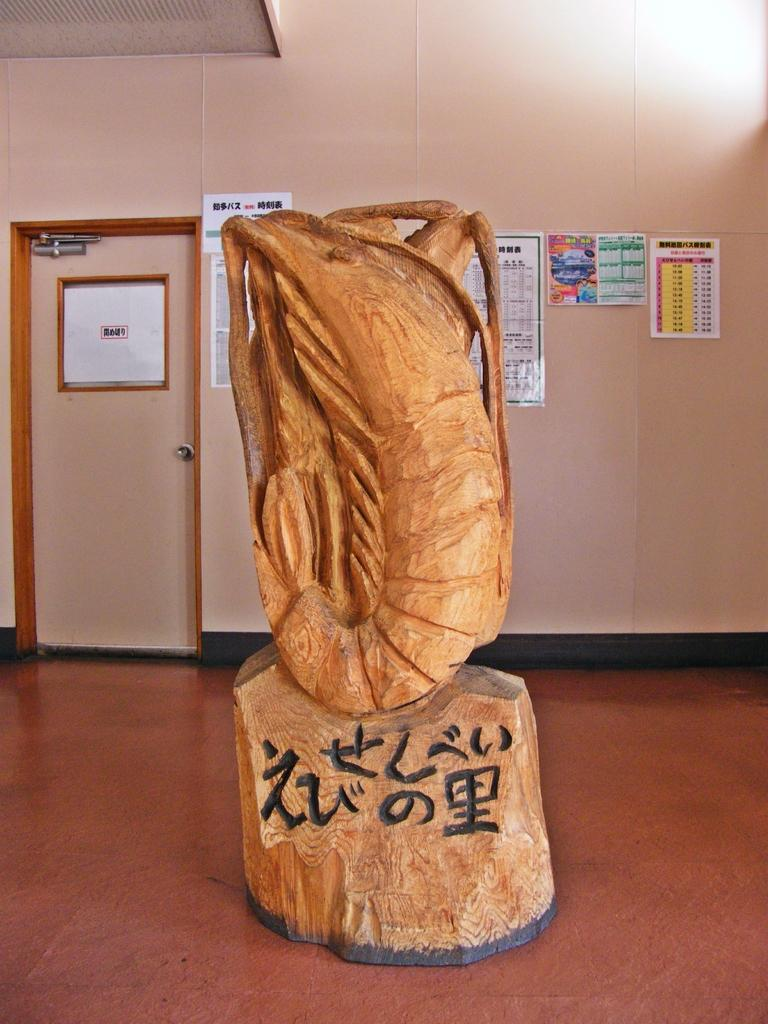Provide a one-sentence caption for the provided image. A large wood carving statue of a shrimp with Asian symbols and lettering at its base. 